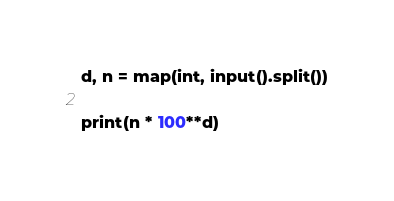Convert code to text. <code><loc_0><loc_0><loc_500><loc_500><_Python_>d, n = map(int, input().split())

print(n * 100**d)</code> 